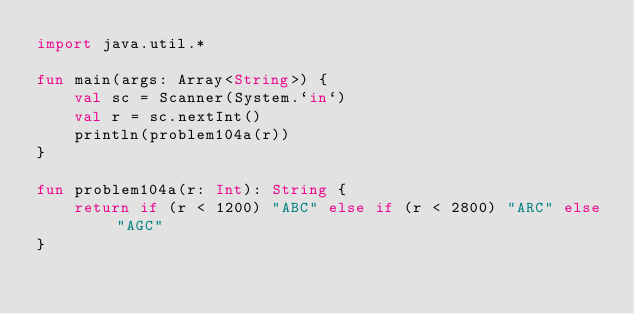Convert code to text. <code><loc_0><loc_0><loc_500><loc_500><_Kotlin_>import java.util.*

fun main(args: Array<String>) {
    val sc = Scanner(System.`in`)
    val r = sc.nextInt()
    println(problem104a(r))
}

fun problem104a(r: Int): String {
    return if (r < 1200) "ABC" else if (r < 2800) "ARC" else "AGC"
}</code> 